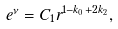<formula> <loc_0><loc_0><loc_500><loc_500>e ^ { \nu } = C _ { 1 } r ^ { 1 - k _ { 0 } + 2 k _ { 2 } } ,</formula> 